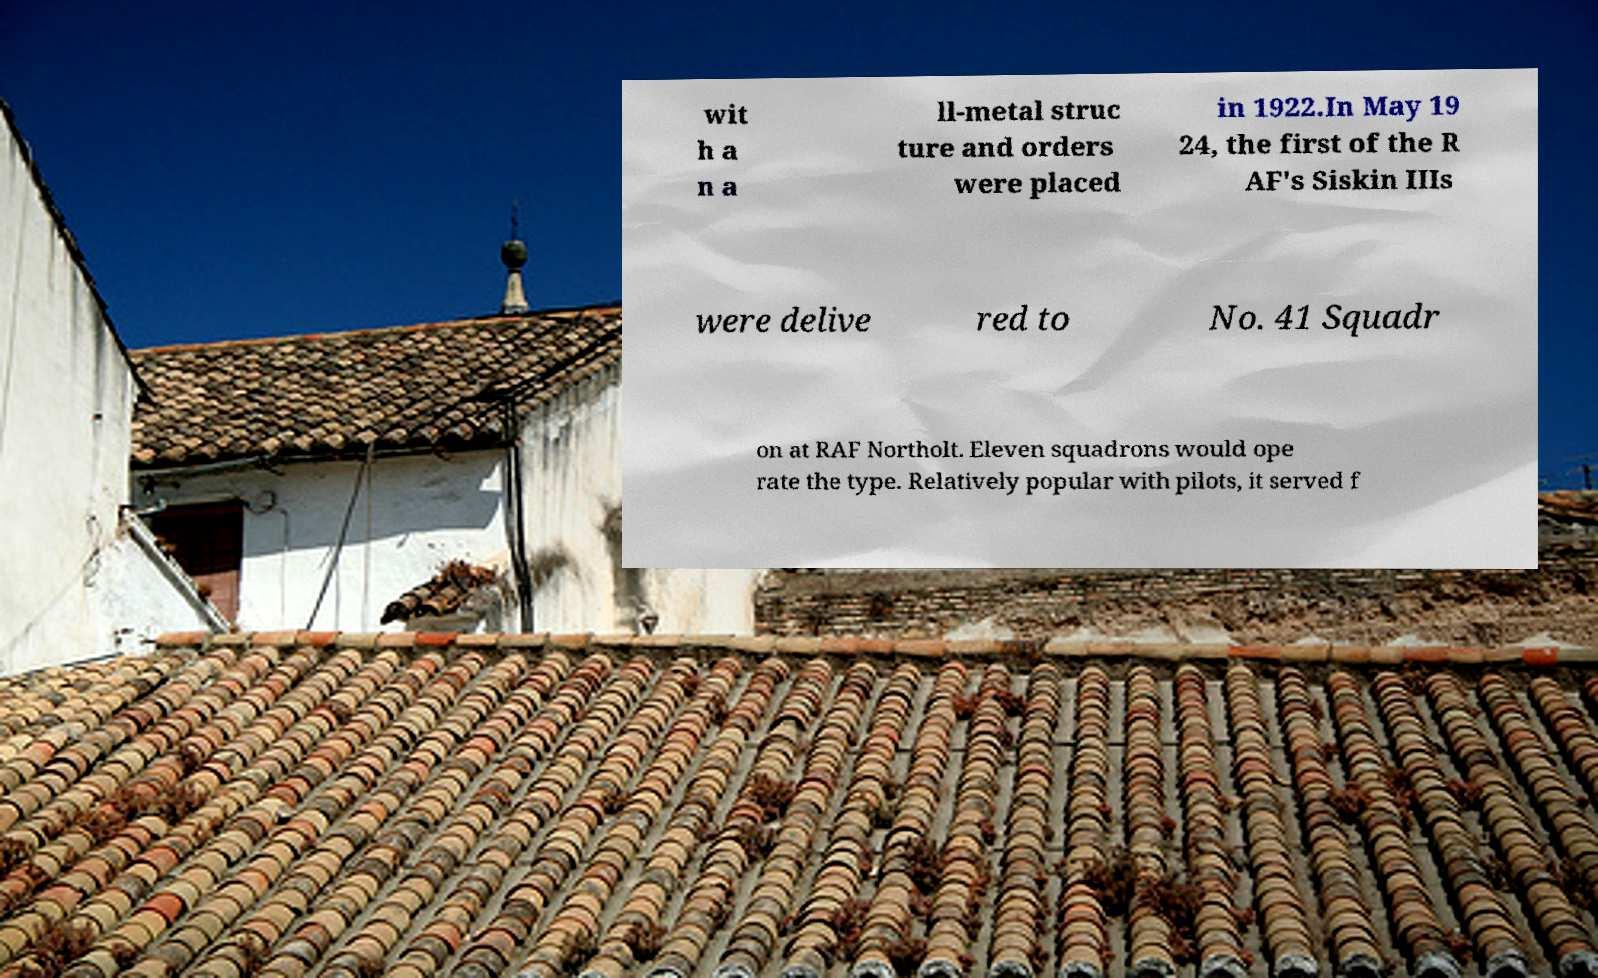What messages or text are displayed in this image? I need them in a readable, typed format. wit h a n a ll-metal struc ture and orders were placed in 1922.In May 19 24, the first of the R AF's Siskin IIIs were delive red to No. 41 Squadr on at RAF Northolt. Eleven squadrons would ope rate the type. Relatively popular with pilots, it served f 